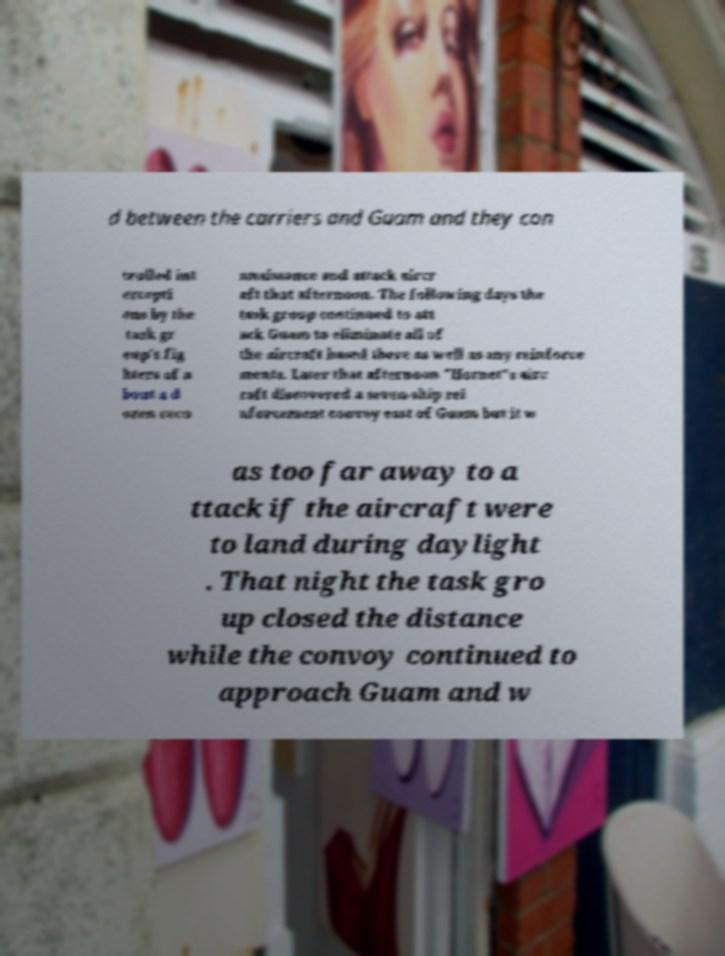Please read and relay the text visible in this image. What does it say? d between the carriers and Guam and they con trolled int ercepti ons by the task gr oup's fig hters of a bout a d ozen reco nnaissance and attack aircr aft that afternoon. The following days the task group continued to att ack Guam to eliminate all of the aircraft based there as well as any reinforce ments. Later that afternoon "Hornet"s airc raft discovered a seven-ship rei nforcement convoy east of Guam but it w as too far away to a ttack if the aircraft were to land during daylight . That night the task gro up closed the distance while the convoy continued to approach Guam and w 